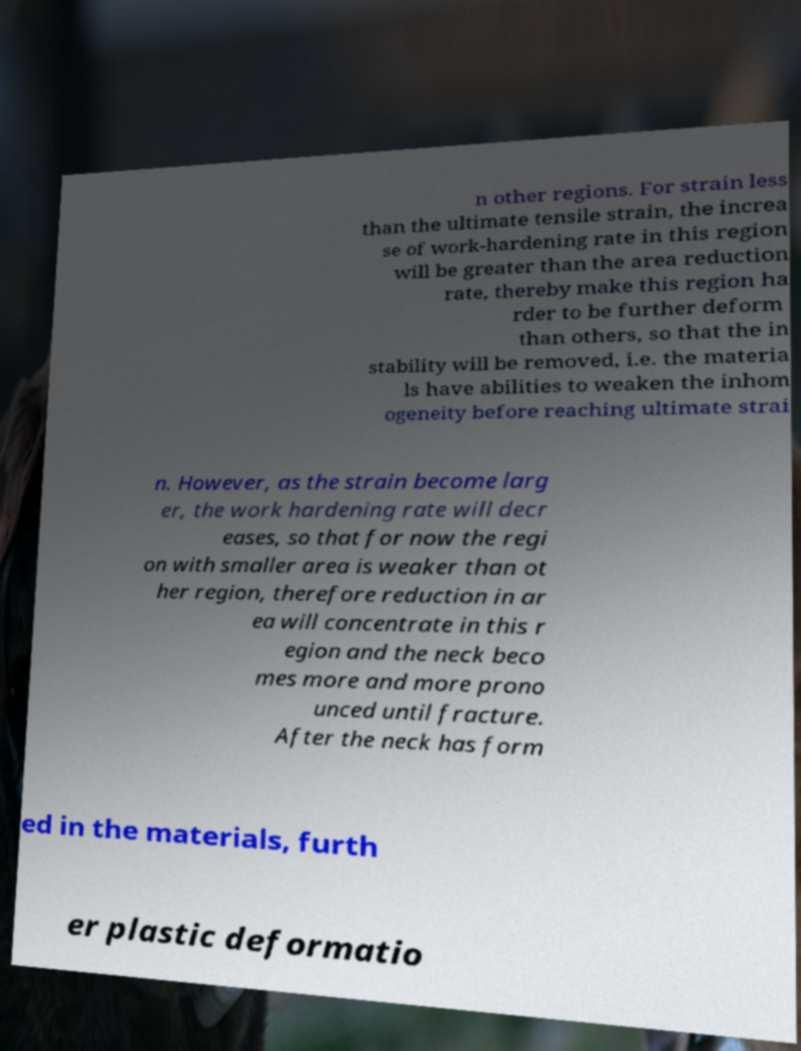What messages or text are displayed in this image? I need them in a readable, typed format. n other regions. For strain less than the ultimate tensile strain, the increa se of work-hardening rate in this region will be greater than the area reduction rate, thereby make this region ha rder to be further deform than others, so that the in stability will be removed, i.e. the materia ls have abilities to weaken the inhom ogeneity before reaching ultimate strai n. However, as the strain become larg er, the work hardening rate will decr eases, so that for now the regi on with smaller area is weaker than ot her region, therefore reduction in ar ea will concentrate in this r egion and the neck beco mes more and more prono unced until fracture. After the neck has form ed in the materials, furth er plastic deformatio 